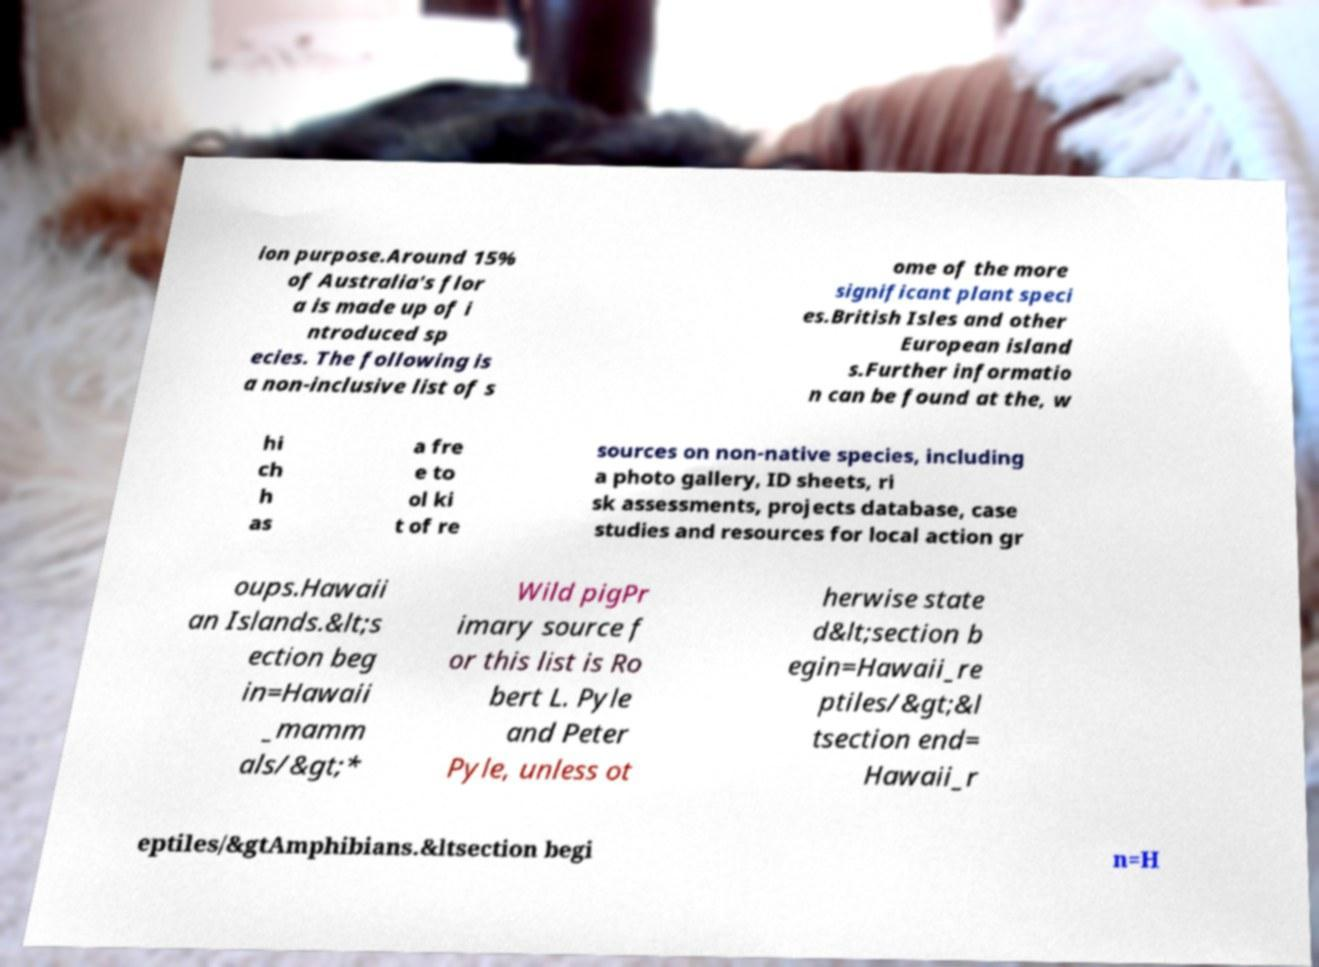What messages or text are displayed in this image? I need them in a readable, typed format. ion purpose.Around 15% of Australia's flor a is made up of i ntroduced sp ecies. The following is a non-inclusive list of s ome of the more significant plant speci es.British Isles and other European island s.Further informatio n can be found at the, w hi ch h as a fre e to ol ki t of re sources on non-native species, including a photo gallery, ID sheets, ri sk assessments, projects database, case studies and resources for local action gr oups.Hawaii an Islands.&lt;s ection beg in=Hawaii _mamm als/&gt;* Wild pigPr imary source f or this list is Ro bert L. Pyle and Peter Pyle, unless ot herwise state d&lt;section b egin=Hawaii_re ptiles/&gt;&l tsection end= Hawaii_r eptiles/&gtAmphibians.&ltsection begi n=H 